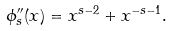Convert formula to latex. <formula><loc_0><loc_0><loc_500><loc_500>\phi _ { s } ^ { \prime \prime } ( x ) = x ^ { s - 2 } + x ^ { - s - 1 } .</formula> 